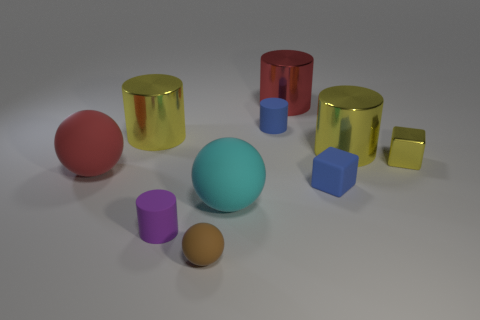Subtract all green spheres. How many yellow cylinders are left? 2 Subtract all big cyan spheres. How many spheres are left? 2 Subtract all red cylinders. How many cylinders are left? 4 Subtract all cubes. How many objects are left? 8 Subtract all purple spheres. Subtract all brown cubes. How many spheres are left? 3 Add 6 tiny blue rubber cylinders. How many tiny blue rubber cylinders are left? 7 Add 7 small brown rubber balls. How many small brown rubber balls exist? 8 Subtract 0 purple blocks. How many objects are left? 10 Subtract all cylinders. Subtract all large blue metal cylinders. How many objects are left? 5 